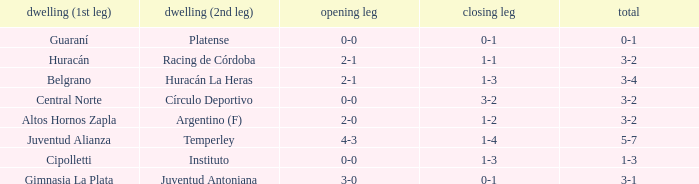Who played at home for the 2nd leg with a score of 1-2? Argentino (F). 